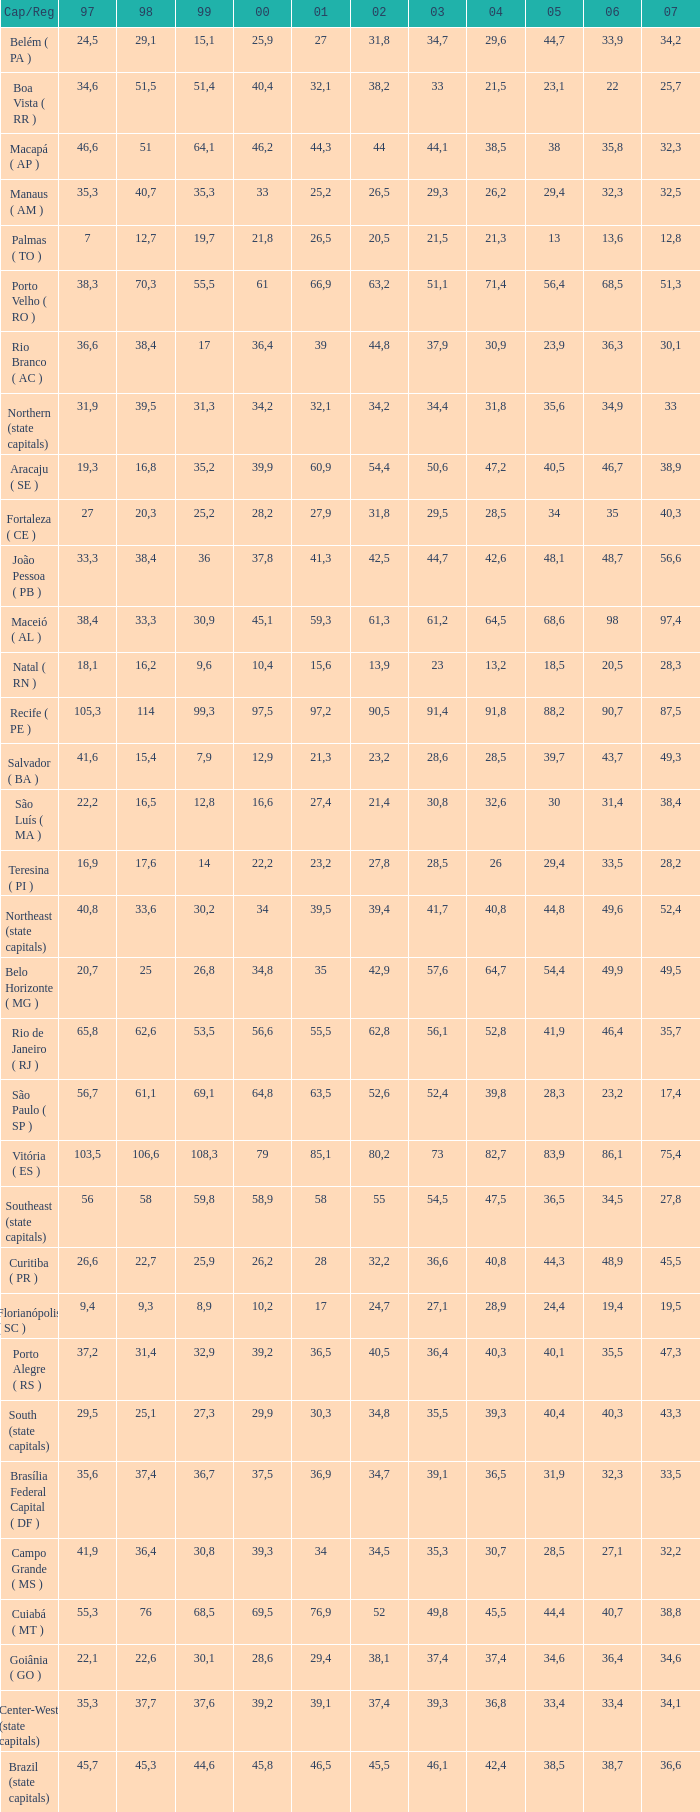How many 2007's have a 2000 greater than 56,6, 23,2 as 2006, and a 1998 greater than 61,1? None. 